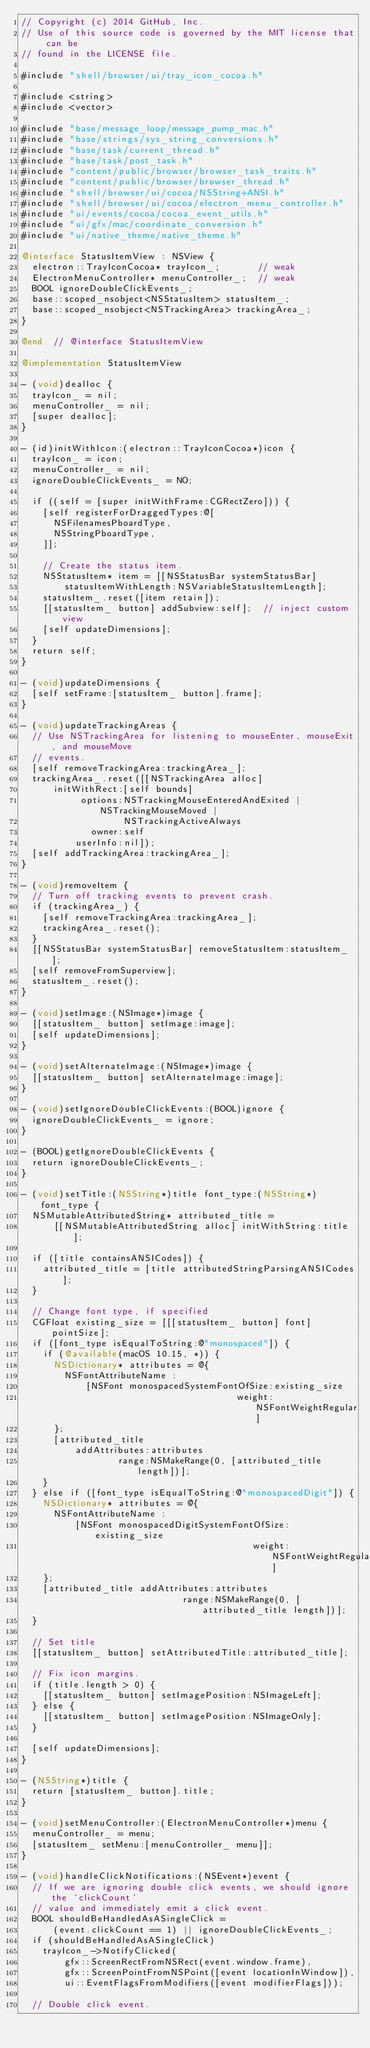Convert code to text. <code><loc_0><loc_0><loc_500><loc_500><_ObjectiveC_>// Copyright (c) 2014 GitHub, Inc.
// Use of this source code is governed by the MIT license that can be
// found in the LICENSE file.

#include "shell/browser/ui/tray_icon_cocoa.h"

#include <string>
#include <vector>

#include "base/message_loop/message_pump_mac.h"
#include "base/strings/sys_string_conversions.h"
#include "base/task/current_thread.h"
#include "base/task/post_task.h"
#include "content/public/browser/browser_task_traits.h"
#include "content/public/browser/browser_thread.h"
#include "shell/browser/ui/cocoa/NSString+ANSI.h"
#include "shell/browser/ui/cocoa/electron_menu_controller.h"
#include "ui/events/cocoa/cocoa_event_utils.h"
#include "ui/gfx/mac/coordinate_conversion.h"
#include "ui/native_theme/native_theme.h"

@interface StatusItemView : NSView {
  electron::TrayIconCocoa* trayIcon_;       // weak
  ElectronMenuController* menuController_;  // weak
  BOOL ignoreDoubleClickEvents_;
  base::scoped_nsobject<NSStatusItem> statusItem_;
  base::scoped_nsobject<NSTrackingArea> trackingArea_;
}

@end  // @interface StatusItemView

@implementation StatusItemView

- (void)dealloc {
  trayIcon_ = nil;
  menuController_ = nil;
  [super dealloc];
}

- (id)initWithIcon:(electron::TrayIconCocoa*)icon {
  trayIcon_ = icon;
  menuController_ = nil;
  ignoreDoubleClickEvents_ = NO;

  if ((self = [super initWithFrame:CGRectZero])) {
    [self registerForDraggedTypes:@[
      NSFilenamesPboardType,
      NSStringPboardType,
    ]];

    // Create the status item.
    NSStatusItem* item = [[NSStatusBar systemStatusBar]
        statusItemWithLength:NSVariableStatusItemLength];
    statusItem_.reset([item retain]);
    [[statusItem_ button] addSubview:self];  // inject custom view
    [self updateDimensions];
  }
  return self;
}

- (void)updateDimensions {
  [self setFrame:[statusItem_ button].frame];
}

- (void)updateTrackingAreas {
  // Use NSTrackingArea for listening to mouseEnter, mouseExit, and mouseMove
  // events.
  [self removeTrackingArea:trackingArea_];
  trackingArea_.reset([[NSTrackingArea alloc]
      initWithRect:[self bounds]
           options:NSTrackingMouseEnteredAndExited | NSTrackingMouseMoved |
                   NSTrackingActiveAlways
             owner:self
          userInfo:nil]);
  [self addTrackingArea:trackingArea_];
}

- (void)removeItem {
  // Turn off tracking events to prevent crash.
  if (trackingArea_) {
    [self removeTrackingArea:trackingArea_];
    trackingArea_.reset();
  }
  [[NSStatusBar systemStatusBar] removeStatusItem:statusItem_];
  [self removeFromSuperview];
  statusItem_.reset();
}

- (void)setImage:(NSImage*)image {
  [[statusItem_ button] setImage:image];
  [self updateDimensions];
}

- (void)setAlternateImage:(NSImage*)image {
  [[statusItem_ button] setAlternateImage:image];
}

- (void)setIgnoreDoubleClickEvents:(BOOL)ignore {
  ignoreDoubleClickEvents_ = ignore;
}

- (BOOL)getIgnoreDoubleClickEvents {
  return ignoreDoubleClickEvents_;
}

- (void)setTitle:(NSString*)title font_type:(NSString*)font_type {
  NSMutableAttributedString* attributed_title =
      [[NSMutableAttributedString alloc] initWithString:title];

  if ([title containsANSICodes]) {
    attributed_title = [title attributedStringParsingANSICodes];
  }

  // Change font type, if specified
  CGFloat existing_size = [[[statusItem_ button] font] pointSize];
  if ([font_type isEqualToString:@"monospaced"]) {
    if (@available(macOS 10.15, *)) {
      NSDictionary* attributes = @{
        NSFontAttributeName :
            [NSFont monospacedSystemFontOfSize:existing_size
                                        weight:NSFontWeightRegular]
      };
      [attributed_title
          addAttributes:attributes
                  range:NSMakeRange(0, [attributed_title length])];
    }
  } else if ([font_type isEqualToString:@"monospacedDigit"]) {
    NSDictionary* attributes = @{
      NSFontAttributeName :
          [NSFont monospacedDigitSystemFontOfSize:existing_size
                                           weight:NSFontWeightRegular]
    };
    [attributed_title addAttributes:attributes
                              range:NSMakeRange(0, [attributed_title length])];
  }

  // Set title
  [[statusItem_ button] setAttributedTitle:attributed_title];

  // Fix icon margins.
  if (title.length > 0) {
    [[statusItem_ button] setImagePosition:NSImageLeft];
  } else {
    [[statusItem_ button] setImagePosition:NSImageOnly];
  }

  [self updateDimensions];
}

- (NSString*)title {
  return [statusItem_ button].title;
}

- (void)setMenuController:(ElectronMenuController*)menu {
  menuController_ = menu;
  [statusItem_ setMenu:[menuController_ menu]];
}

- (void)handleClickNotifications:(NSEvent*)event {
  // If we are ignoring double click events, we should ignore the `clickCount`
  // value and immediately emit a click event.
  BOOL shouldBeHandledAsASingleClick =
      (event.clickCount == 1) || ignoreDoubleClickEvents_;
  if (shouldBeHandledAsASingleClick)
    trayIcon_->NotifyClicked(
        gfx::ScreenRectFromNSRect(event.window.frame),
        gfx::ScreenPointFromNSPoint([event locationInWindow]),
        ui::EventFlagsFromModifiers([event modifierFlags]));

  // Double click event.</code> 